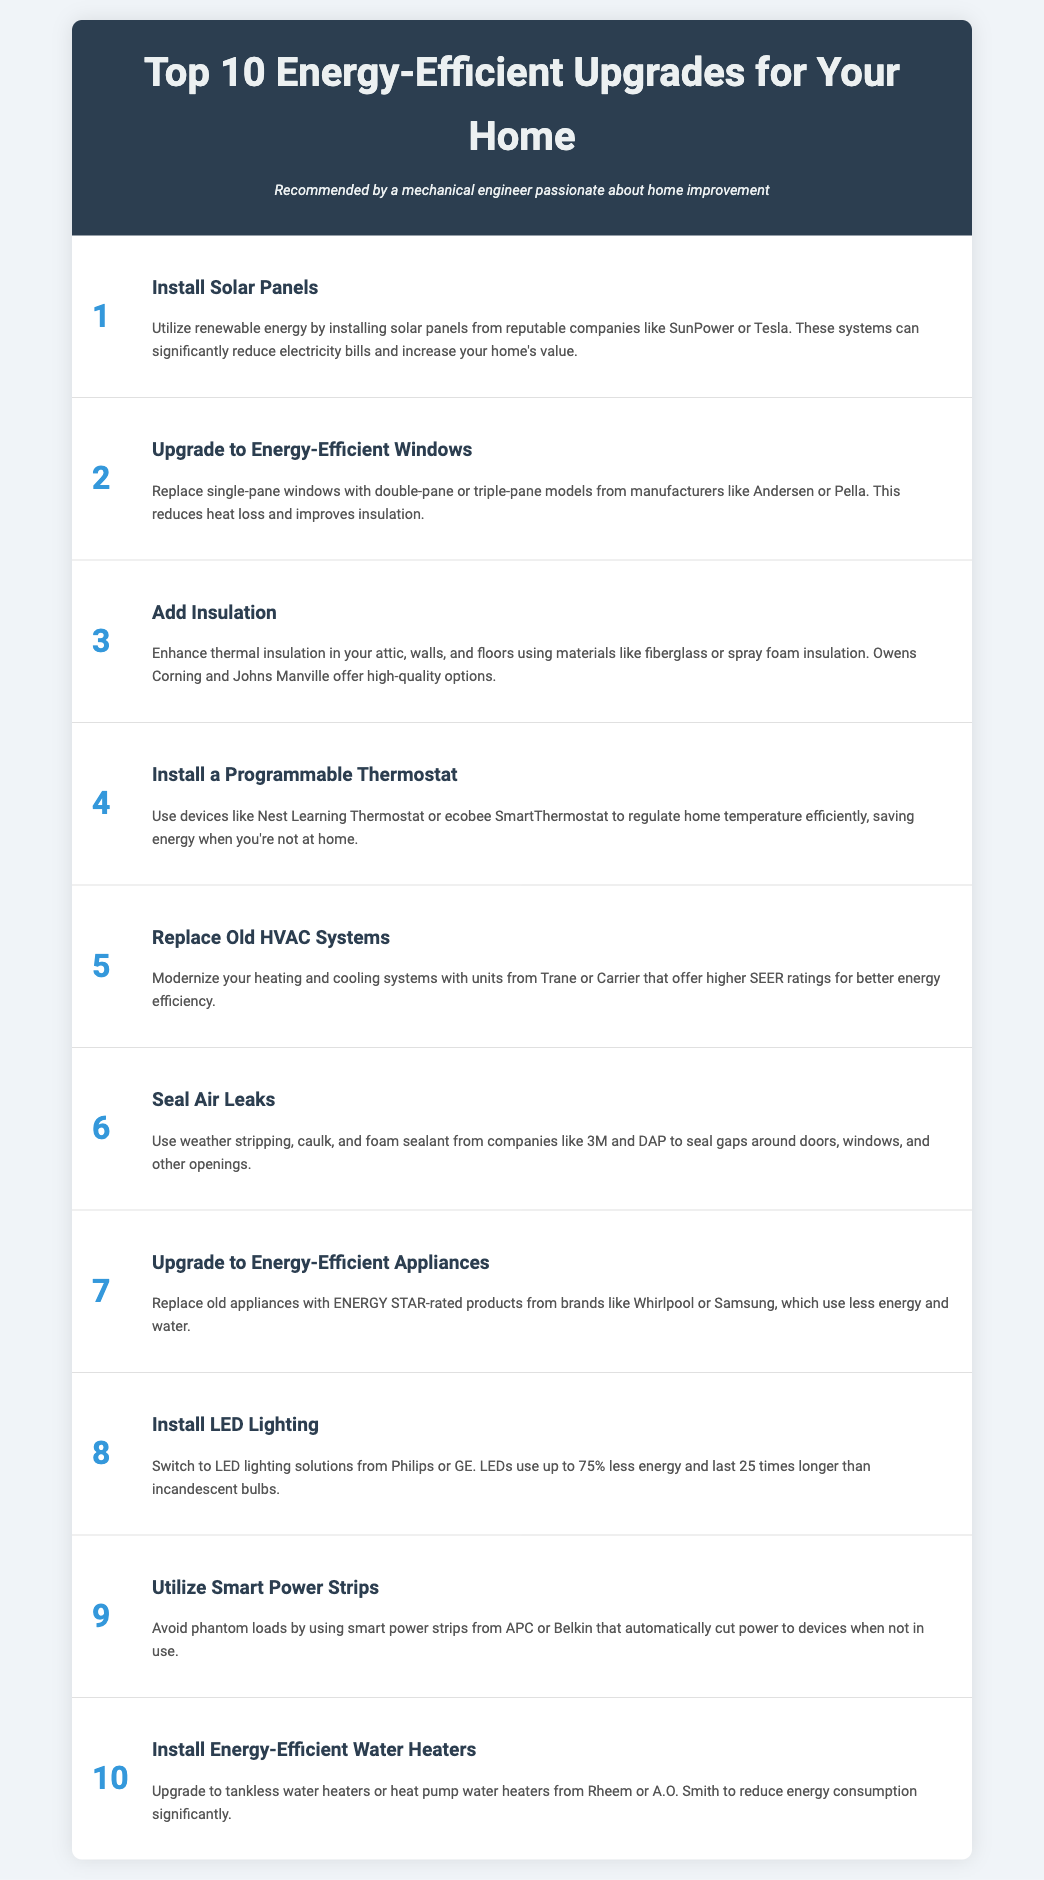what is the title of the document? The title of the document is prominently displayed at the top of the page.
Answer: Top 10 Energy-Efficient Upgrades for Your Home who recommends these upgrades? The recommendation is stated in the persona section of the document.
Answer: A mechanical engineer what is the ranking of solar panels in the upgrades? The ranking of each upgrade is indicated next to each item in the list.
Answer: 1 which product is suggested for energy-efficient windows? The document mentions specific manufacturers for each upgrade.
Answer: Andersen what type of insulation is recommended? The description of insulation mentions specific types that can be used for energy efficiency.
Answer: fiberglass or spray foam insulation how many upgrades are listed in the document? The total number of upgrades is indicated by the list format and sequence numbers.
Answer: 10 what is the main benefit of installing energy-efficient appliances? The document outlines the advantages of upgrading appliances in the description section.
Answer: use less energy and water which brand is suggested for smart power strips? Specific brands are mentioned for each upgrade throughout the document.
Answer: APC what is the upgrade mentioned for water heating systems? The document specifically describes the type of water heaters to install for energy efficiency.
Answer: tankless water heaters or heat pump water heaters what energy-saving measure is associated with sealing air leaks? The description for sealing air leaks provides a specific purpose for this upgrade.
Answer: avoid phantom loads 